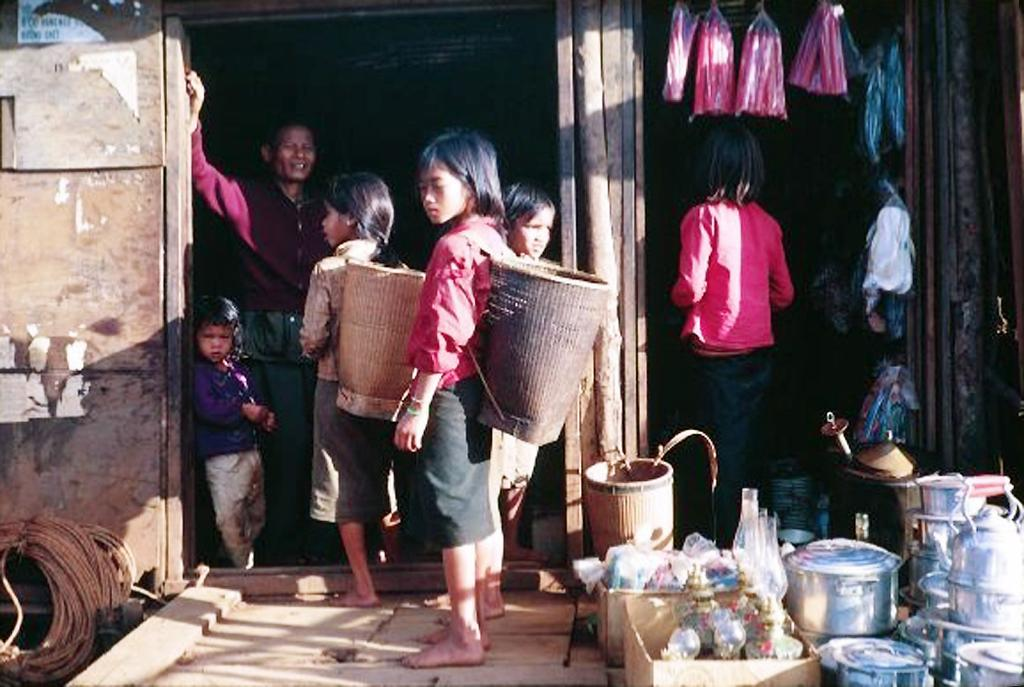What is the main subject of the image? The main subject of the image is a group of people standing. What objects can be seen in the image besides the people? There are glasses and utensils visible in the image. What type of door can be seen in the image? There is a wooden door in the image. Can you see any quince being eaten by the people in the image? There is no mention of quince in the image, so it cannot be determined if anyone is eating it. 